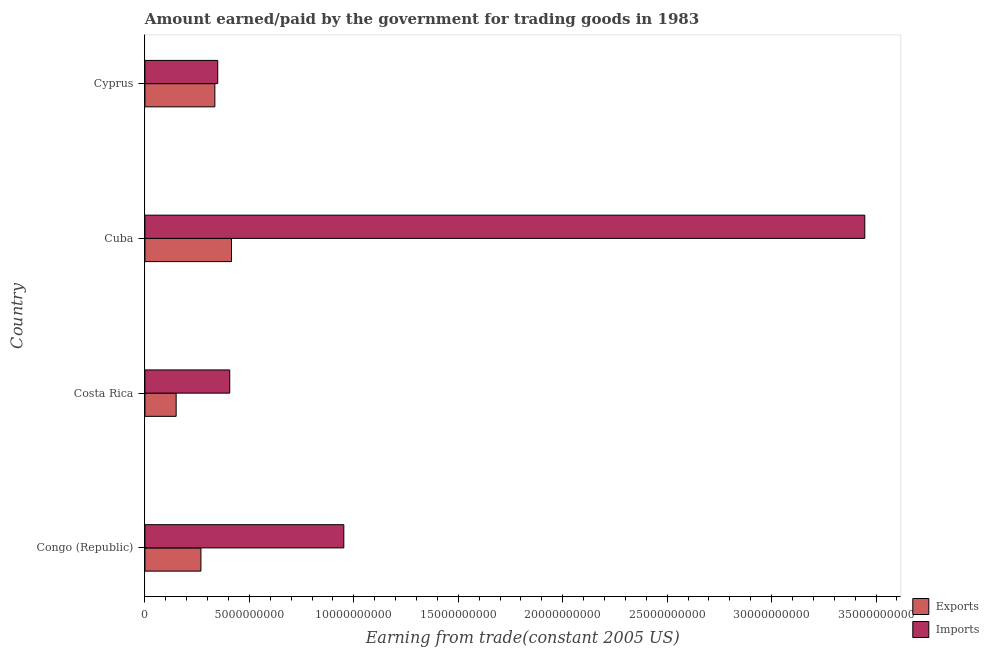How many different coloured bars are there?
Give a very brief answer. 2. How many groups of bars are there?
Keep it short and to the point. 4. Are the number of bars per tick equal to the number of legend labels?
Provide a succinct answer. Yes. Are the number of bars on each tick of the Y-axis equal?
Your response must be concise. Yes. How many bars are there on the 2nd tick from the top?
Keep it short and to the point. 2. What is the label of the 4th group of bars from the top?
Ensure brevity in your answer.  Congo (Republic). What is the amount earned from exports in Congo (Republic)?
Offer a terse response. 2.68e+09. Across all countries, what is the maximum amount paid for imports?
Provide a succinct answer. 3.45e+1. Across all countries, what is the minimum amount paid for imports?
Your response must be concise. 3.49e+09. In which country was the amount earned from exports maximum?
Provide a succinct answer. Cuba. What is the total amount paid for imports in the graph?
Provide a short and direct response. 5.15e+1. What is the difference between the amount earned from exports in Congo (Republic) and that in Cuba?
Your answer should be very brief. -1.46e+09. What is the difference between the amount earned from exports in Costa Rica and the amount paid for imports in Cyprus?
Your answer should be compact. -1.99e+09. What is the average amount earned from exports per country?
Your answer should be compact. 2.92e+09. What is the difference between the amount earned from exports and amount paid for imports in Congo (Republic)?
Offer a very short reply. -6.84e+09. What is the ratio of the amount paid for imports in Congo (Republic) to that in Cuba?
Offer a very short reply. 0.28. Is the difference between the amount earned from exports in Congo (Republic) and Cuba greater than the difference between the amount paid for imports in Congo (Republic) and Cuba?
Provide a succinct answer. Yes. What is the difference between the highest and the second highest amount earned from exports?
Offer a terse response. 7.95e+08. What is the difference between the highest and the lowest amount paid for imports?
Ensure brevity in your answer.  3.10e+1. What does the 2nd bar from the top in Costa Rica represents?
Offer a terse response. Exports. What does the 2nd bar from the bottom in Costa Rica represents?
Your answer should be very brief. Imports. How many bars are there?
Keep it short and to the point. 8. Are all the bars in the graph horizontal?
Ensure brevity in your answer.  Yes. Does the graph contain any zero values?
Offer a terse response. No. How are the legend labels stacked?
Your response must be concise. Vertical. What is the title of the graph?
Offer a terse response. Amount earned/paid by the government for trading goods in 1983. Does "Underweight" appear as one of the legend labels in the graph?
Ensure brevity in your answer.  No. What is the label or title of the X-axis?
Ensure brevity in your answer.  Earning from trade(constant 2005 US). What is the label or title of the Y-axis?
Offer a very short reply. Country. What is the Earning from trade(constant 2005 US) in Exports in Congo (Republic)?
Provide a short and direct response. 2.68e+09. What is the Earning from trade(constant 2005 US) of Imports in Congo (Republic)?
Your response must be concise. 9.52e+09. What is the Earning from trade(constant 2005 US) of Exports in Costa Rica?
Your response must be concise. 1.50e+09. What is the Earning from trade(constant 2005 US) in Imports in Costa Rica?
Ensure brevity in your answer.  4.06e+09. What is the Earning from trade(constant 2005 US) in Exports in Cuba?
Your answer should be very brief. 4.14e+09. What is the Earning from trade(constant 2005 US) of Imports in Cuba?
Keep it short and to the point. 3.45e+1. What is the Earning from trade(constant 2005 US) in Exports in Cyprus?
Make the answer very short. 3.35e+09. What is the Earning from trade(constant 2005 US) of Imports in Cyprus?
Your answer should be compact. 3.49e+09. Across all countries, what is the maximum Earning from trade(constant 2005 US) of Exports?
Provide a short and direct response. 4.14e+09. Across all countries, what is the maximum Earning from trade(constant 2005 US) in Imports?
Your response must be concise. 3.45e+1. Across all countries, what is the minimum Earning from trade(constant 2005 US) in Exports?
Your answer should be very brief. 1.50e+09. Across all countries, what is the minimum Earning from trade(constant 2005 US) of Imports?
Your response must be concise. 3.49e+09. What is the total Earning from trade(constant 2005 US) in Exports in the graph?
Keep it short and to the point. 1.17e+1. What is the total Earning from trade(constant 2005 US) in Imports in the graph?
Your answer should be compact. 5.15e+1. What is the difference between the Earning from trade(constant 2005 US) of Exports in Congo (Republic) and that in Costa Rica?
Offer a very short reply. 1.19e+09. What is the difference between the Earning from trade(constant 2005 US) of Imports in Congo (Republic) and that in Costa Rica?
Your answer should be compact. 5.46e+09. What is the difference between the Earning from trade(constant 2005 US) of Exports in Congo (Republic) and that in Cuba?
Provide a short and direct response. -1.46e+09. What is the difference between the Earning from trade(constant 2005 US) of Imports in Congo (Republic) and that in Cuba?
Ensure brevity in your answer.  -2.49e+1. What is the difference between the Earning from trade(constant 2005 US) of Exports in Congo (Republic) and that in Cyprus?
Make the answer very short. -6.68e+08. What is the difference between the Earning from trade(constant 2005 US) of Imports in Congo (Republic) and that in Cyprus?
Offer a terse response. 6.04e+09. What is the difference between the Earning from trade(constant 2005 US) of Exports in Costa Rica and that in Cuba?
Your response must be concise. -2.65e+09. What is the difference between the Earning from trade(constant 2005 US) of Imports in Costa Rica and that in Cuba?
Your answer should be compact. -3.04e+1. What is the difference between the Earning from trade(constant 2005 US) of Exports in Costa Rica and that in Cyprus?
Offer a very short reply. -1.85e+09. What is the difference between the Earning from trade(constant 2005 US) in Imports in Costa Rica and that in Cyprus?
Provide a short and direct response. 5.74e+08. What is the difference between the Earning from trade(constant 2005 US) in Exports in Cuba and that in Cyprus?
Provide a succinct answer. 7.95e+08. What is the difference between the Earning from trade(constant 2005 US) in Imports in Cuba and that in Cyprus?
Your response must be concise. 3.10e+1. What is the difference between the Earning from trade(constant 2005 US) of Exports in Congo (Republic) and the Earning from trade(constant 2005 US) of Imports in Costa Rica?
Ensure brevity in your answer.  -1.38e+09. What is the difference between the Earning from trade(constant 2005 US) of Exports in Congo (Republic) and the Earning from trade(constant 2005 US) of Imports in Cuba?
Give a very brief answer. -3.18e+1. What is the difference between the Earning from trade(constant 2005 US) in Exports in Congo (Republic) and the Earning from trade(constant 2005 US) in Imports in Cyprus?
Your answer should be compact. -8.05e+08. What is the difference between the Earning from trade(constant 2005 US) of Exports in Costa Rica and the Earning from trade(constant 2005 US) of Imports in Cuba?
Ensure brevity in your answer.  -3.30e+1. What is the difference between the Earning from trade(constant 2005 US) of Exports in Costa Rica and the Earning from trade(constant 2005 US) of Imports in Cyprus?
Keep it short and to the point. -1.99e+09. What is the difference between the Earning from trade(constant 2005 US) in Exports in Cuba and the Earning from trade(constant 2005 US) in Imports in Cyprus?
Your answer should be compact. 6.58e+08. What is the average Earning from trade(constant 2005 US) in Exports per country?
Make the answer very short. 2.92e+09. What is the average Earning from trade(constant 2005 US) of Imports per country?
Keep it short and to the point. 1.29e+1. What is the difference between the Earning from trade(constant 2005 US) of Exports and Earning from trade(constant 2005 US) of Imports in Congo (Republic)?
Your answer should be compact. -6.84e+09. What is the difference between the Earning from trade(constant 2005 US) in Exports and Earning from trade(constant 2005 US) in Imports in Costa Rica?
Offer a terse response. -2.56e+09. What is the difference between the Earning from trade(constant 2005 US) of Exports and Earning from trade(constant 2005 US) of Imports in Cuba?
Offer a terse response. -3.03e+1. What is the difference between the Earning from trade(constant 2005 US) of Exports and Earning from trade(constant 2005 US) of Imports in Cyprus?
Give a very brief answer. -1.37e+08. What is the ratio of the Earning from trade(constant 2005 US) of Exports in Congo (Republic) to that in Costa Rica?
Your answer should be compact. 1.79. What is the ratio of the Earning from trade(constant 2005 US) of Imports in Congo (Republic) to that in Costa Rica?
Your response must be concise. 2.35. What is the ratio of the Earning from trade(constant 2005 US) in Exports in Congo (Republic) to that in Cuba?
Your answer should be very brief. 0.65. What is the ratio of the Earning from trade(constant 2005 US) of Imports in Congo (Republic) to that in Cuba?
Make the answer very short. 0.28. What is the ratio of the Earning from trade(constant 2005 US) of Exports in Congo (Republic) to that in Cyprus?
Your answer should be very brief. 0.8. What is the ratio of the Earning from trade(constant 2005 US) of Imports in Congo (Republic) to that in Cyprus?
Give a very brief answer. 2.73. What is the ratio of the Earning from trade(constant 2005 US) of Exports in Costa Rica to that in Cuba?
Give a very brief answer. 0.36. What is the ratio of the Earning from trade(constant 2005 US) in Imports in Costa Rica to that in Cuba?
Offer a terse response. 0.12. What is the ratio of the Earning from trade(constant 2005 US) in Exports in Costa Rica to that in Cyprus?
Your response must be concise. 0.45. What is the ratio of the Earning from trade(constant 2005 US) in Imports in Costa Rica to that in Cyprus?
Provide a succinct answer. 1.16. What is the ratio of the Earning from trade(constant 2005 US) in Exports in Cuba to that in Cyprus?
Make the answer very short. 1.24. What is the ratio of the Earning from trade(constant 2005 US) in Imports in Cuba to that in Cyprus?
Your answer should be compact. 9.89. What is the difference between the highest and the second highest Earning from trade(constant 2005 US) of Exports?
Keep it short and to the point. 7.95e+08. What is the difference between the highest and the second highest Earning from trade(constant 2005 US) in Imports?
Your answer should be very brief. 2.49e+1. What is the difference between the highest and the lowest Earning from trade(constant 2005 US) of Exports?
Offer a terse response. 2.65e+09. What is the difference between the highest and the lowest Earning from trade(constant 2005 US) of Imports?
Your answer should be compact. 3.10e+1. 